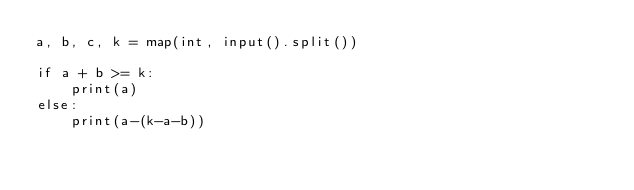Convert code to text. <code><loc_0><loc_0><loc_500><loc_500><_Python_>a, b, c, k = map(int, input().split())

if a + b >= k:
    print(a)
else:
    print(a-(k-a-b))
</code> 